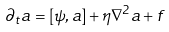Convert formula to latex. <formula><loc_0><loc_0><loc_500><loc_500>\partial _ { t } a = [ \psi , a ] + \eta \nabla ^ { 2 } a + f</formula> 